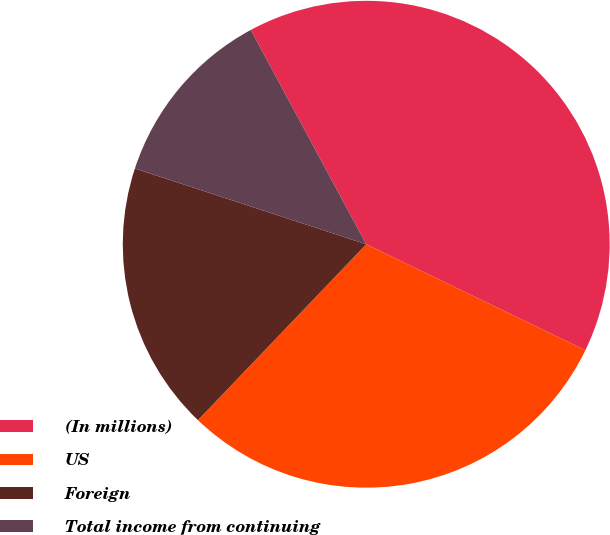Convert chart to OTSL. <chart><loc_0><loc_0><loc_500><loc_500><pie_chart><fcel>(In millions)<fcel>US<fcel>Foreign<fcel>Total income from continuing<nl><fcel>40.04%<fcel>29.98%<fcel>17.89%<fcel>12.1%<nl></chart> 